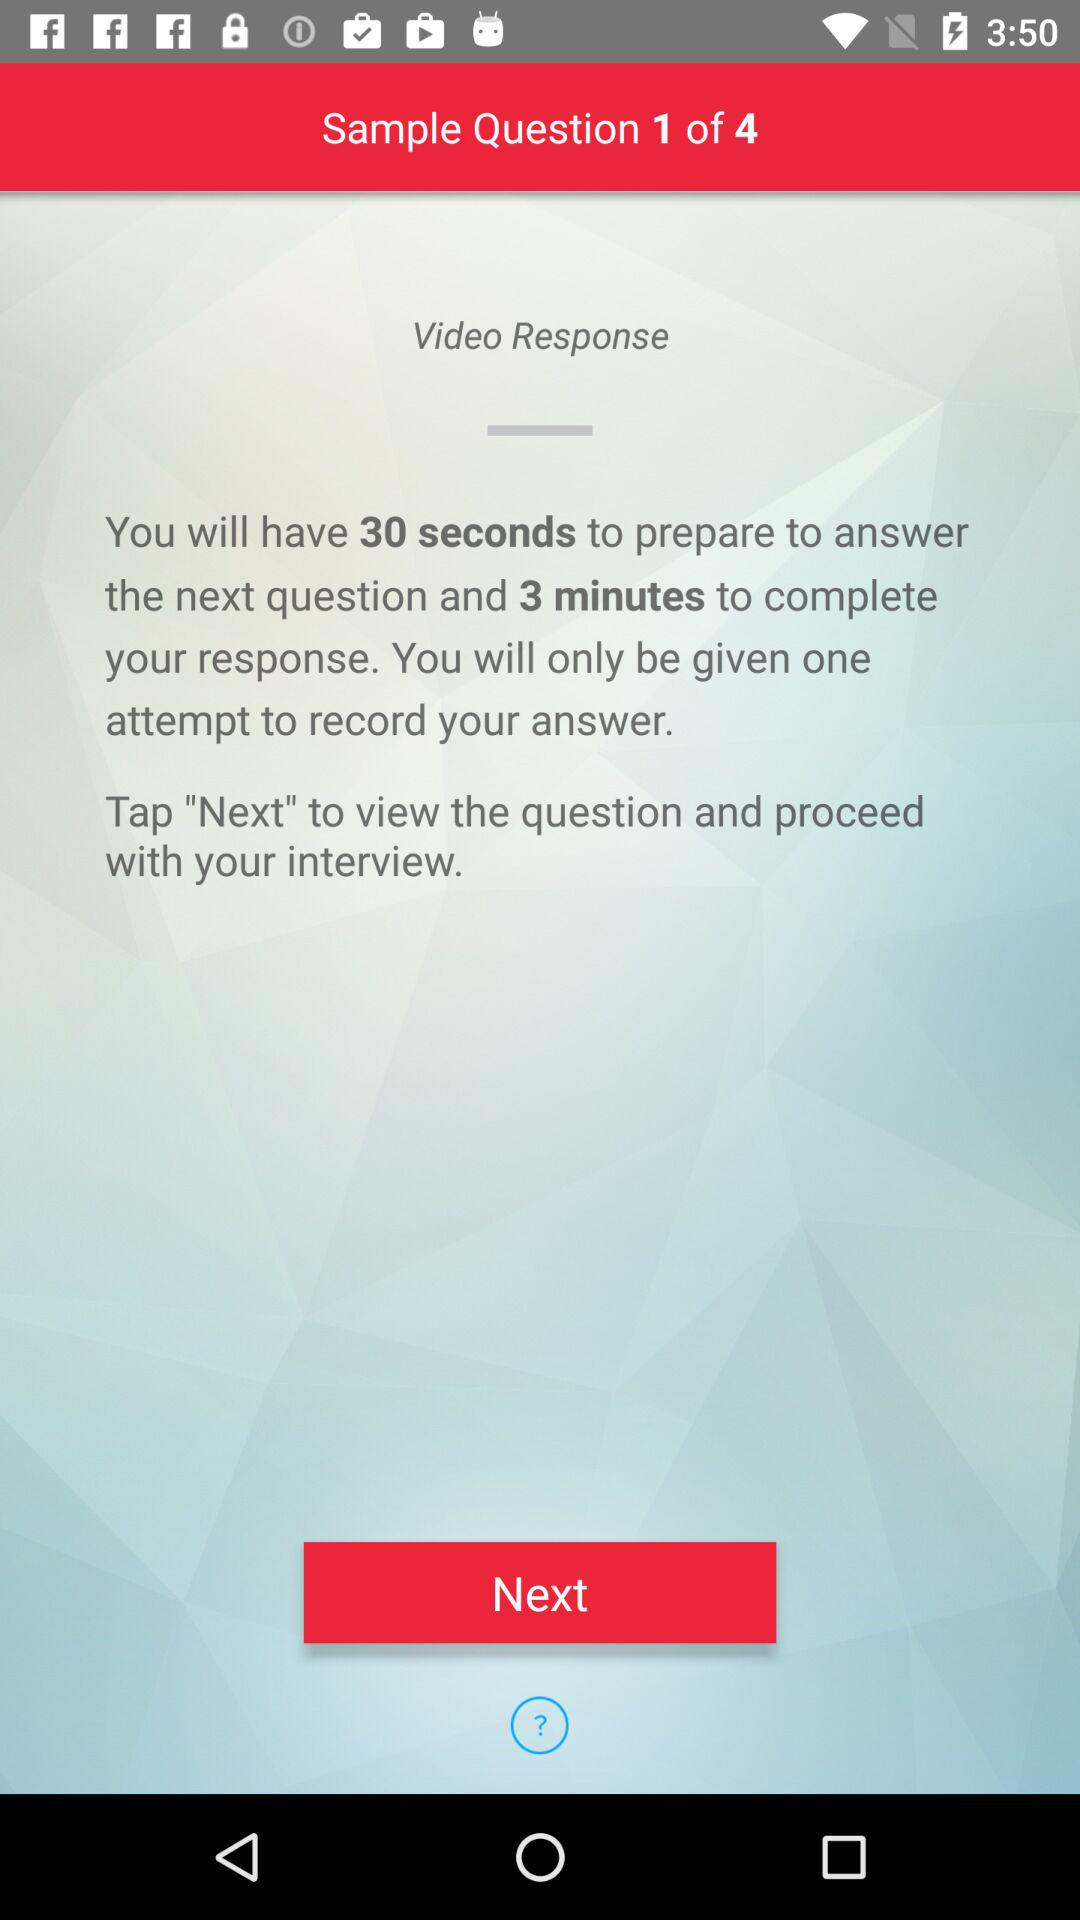How many seconds are you given to prepare to answer the next question?
Answer the question using a single word or phrase. 30 